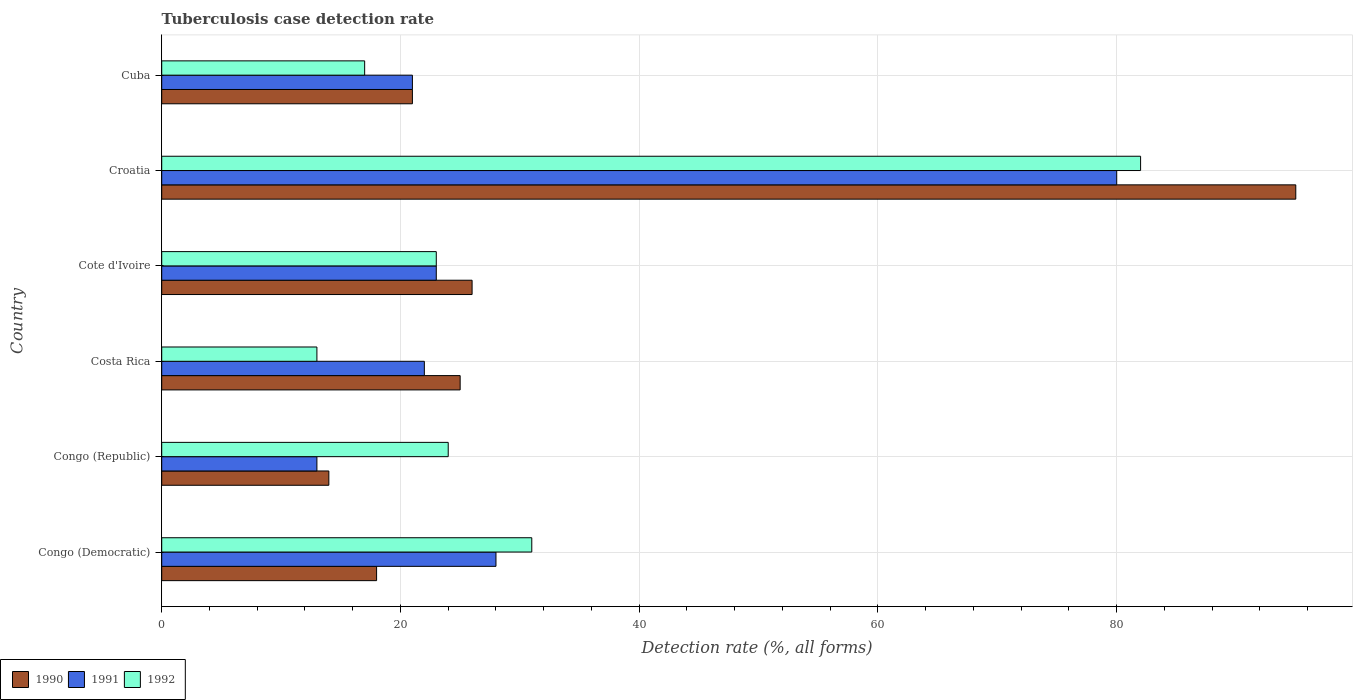How many groups of bars are there?
Make the answer very short. 6. Are the number of bars per tick equal to the number of legend labels?
Give a very brief answer. Yes. How many bars are there on the 4th tick from the bottom?
Keep it short and to the point. 3. What is the label of the 1st group of bars from the top?
Give a very brief answer. Cuba. In how many cases, is the number of bars for a given country not equal to the number of legend labels?
Provide a short and direct response. 0. What is the tuberculosis case detection rate in in 1992 in Croatia?
Your answer should be compact. 82. Across all countries, what is the maximum tuberculosis case detection rate in in 1992?
Give a very brief answer. 82. In which country was the tuberculosis case detection rate in in 1992 maximum?
Keep it short and to the point. Croatia. What is the total tuberculosis case detection rate in in 1991 in the graph?
Provide a succinct answer. 187. What is the difference between the tuberculosis case detection rate in in 1992 in Croatia and that in Cuba?
Your response must be concise. 65. What is the difference between the tuberculosis case detection rate in in 1990 in Costa Rica and the tuberculosis case detection rate in in 1991 in Congo (Democratic)?
Offer a very short reply. -3. What is the average tuberculosis case detection rate in in 1990 per country?
Your answer should be very brief. 33.17. What is the difference between the tuberculosis case detection rate in in 1990 and tuberculosis case detection rate in in 1991 in Cuba?
Your response must be concise. 0. In how many countries, is the tuberculosis case detection rate in in 1991 greater than 76 %?
Provide a short and direct response. 1. What is the ratio of the tuberculosis case detection rate in in 1990 in Costa Rica to that in Croatia?
Offer a terse response. 0.26. What is the difference between the highest and the lowest tuberculosis case detection rate in in 1990?
Your answer should be compact. 81. In how many countries, is the tuberculosis case detection rate in in 1990 greater than the average tuberculosis case detection rate in in 1990 taken over all countries?
Keep it short and to the point. 1. Is it the case that in every country, the sum of the tuberculosis case detection rate in in 1992 and tuberculosis case detection rate in in 1991 is greater than the tuberculosis case detection rate in in 1990?
Provide a short and direct response. Yes. What is the difference between two consecutive major ticks on the X-axis?
Provide a succinct answer. 20. Does the graph contain any zero values?
Provide a succinct answer. No. Does the graph contain grids?
Provide a succinct answer. Yes. How many legend labels are there?
Provide a succinct answer. 3. What is the title of the graph?
Offer a terse response. Tuberculosis case detection rate. What is the label or title of the X-axis?
Make the answer very short. Detection rate (%, all forms). What is the Detection rate (%, all forms) in 1990 in Congo (Democratic)?
Your answer should be compact. 18. What is the Detection rate (%, all forms) of 1991 in Congo (Democratic)?
Your answer should be very brief. 28. What is the Detection rate (%, all forms) in 1990 in Congo (Republic)?
Provide a succinct answer. 14. What is the Detection rate (%, all forms) of 1991 in Congo (Republic)?
Give a very brief answer. 13. What is the Detection rate (%, all forms) in 1992 in Costa Rica?
Provide a succinct answer. 13. What is the Detection rate (%, all forms) of 1990 in Cote d'Ivoire?
Your answer should be very brief. 26. What is the Detection rate (%, all forms) in 1991 in Cote d'Ivoire?
Offer a terse response. 23. What is the Detection rate (%, all forms) in 1992 in Croatia?
Provide a succinct answer. 82. What is the Detection rate (%, all forms) in 1990 in Cuba?
Offer a terse response. 21. What is the Detection rate (%, all forms) of 1991 in Cuba?
Offer a terse response. 21. Across all countries, what is the maximum Detection rate (%, all forms) in 1990?
Offer a terse response. 95. Across all countries, what is the maximum Detection rate (%, all forms) in 1991?
Ensure brevity in your answer.  80. Across all countries, what is the minimum Detection rate (%, all forms) of 1990?
Your answer should be very brief. 14. Across all countries, what is the minimum Detection rate (%, all forms) of 1991?
Provide a succinct answer. 13. What is the total Detection rate (%, all forms) of 1990 in the graph?
Keep it short and to the point. 199. What is the total Detection rate (%, all forms) of 1991 in the graph?
Your response must be concise. 187. What is the total Detection rate (%, all forms) of 1992 in the graph?
Give a very brief answer. 190. What is the difference between the Detection rate (%, all forms) in 1992 in Congo (Democratic) and that in Congo (Republic)?
Keep it short and to the point. 7. What is the difference between the Detection rate (%, all forms) of 1992 in Congo (Democratic) and that in Costa Rica?
Provide a short and direct response. 18. What is the difference between the Detection rate (%, all forms) in 1990 in Congo (Democratic) and that in Cote d'Ivoire?
Keep it short and to the point. -8. What is the difference between the Detection rate (%, all forms) in 1991 in Congo (Democratic) and that in Cote d'Ivoire?
Your answer should be very brief. 5. What is the difference between the Detection rate (%, all forms) in 1992 in Congo (Democratic) and that in Cote d'Ivoire?
Your response must be concise. 8. What is the difference between the Detection rate (%, all forms) in 1990 in Congo (Democratic) and that in Croatia?
Offer a very short reply. -77. What is the difference between the Detection rate (%, all forms) in 1991 in Congo (Democratic) and that in Croatia?
Make the answer very short. -52. What is the difference between the Detection rate (%, all forms) of 1992 in Congo (Democratic) and that in Croatia?
Your answer should be compact. -51. What is the difference between the Detection rate (%, all forms) in 1990 in Congo (Democratic) and that in Cuba?
Provide a short and direct response. -3. What is the difference between the Detection rate (%, all forms) in 1991 in Congo (Democratic) and that in Cuba?
Your answer should be very brief. 7. What is the difference between the Detection rate (%, all forms) of 1992 in Congo (Democratic) and that in Cuba?
Provide a short and direct response. 14. What is the difference between the Detection rate (%, all forms) in 1991 in Congo (Republic) and that in Costa Rica?
Offer a terse response. -9. What is the difference between the Detection rate (%, all forms) of 1991 in Congo (Republic) and that in Cote d'Ivoire?
Your answer should be compact. -10. What is the difference between the Detection rate (%, all forms) of 1992 in Congo (Republic) and that in Cote d'Ivoire?
Ensure brevity in your answer.  1. What is the difference between the Detection rate (%, all forms) of 1990 in Congo (Republic) and that in Croatia?
Ensure brevity in your answer.  -81. What is the difference between the Detection rate (%, all forms) in 1991 in Congo (Republic) and that in Croatia?
Your answer should be compact. -67. What is the difference between the Detection rate (%, all forms) in 1992 in Congo (Republic) and that in Croatia?
Your answer should be compact. -58. What is the difference between the Detection rate (%, all forms) of 1990 in Congo (Republic) and that in Cuba?
Provide a succinct answer. -7. What is the difference between the Detection rate (%, all forms) of 1991 in Congo (Republic) and that in Cuba?
Keep it short and to the point. -8. What is the difference between the Detection rate (%, all forms) in 1992 in Congo (Republic) and that in Cuba?
Keep it short and to the point. 7. What is the difference between the Detection rate (%, all forms) of 1991 in Costa Rica and that in Cote d'Ivoire?
Make the answer very short. -1. What is the difference between the Detection rate (%, all forms) of 1992 in Costa Rica and that in Cote d'Ivoire?
Provide a succinct answer. -10. What is the difference between the Detection rate (%, all forms) in 1990 in Costa Rica and that in Croatia?
Provide a succinct answer. -70. What is the difference between the Detection rate (%, all forms) of 1991 in Costa Rica and that in Croatia?
Ensure brevity in your answer.  -58. What is the difference between the Detection rate (%, all forms) in 1992 in Costa Rica and that in Croatia?
Provide a succinct answer. -69. What is the difference between the Detection rate (%, all forms) in 1990 in Costa Rica and that in Cuba?
Provide a short and direct response. 4. What is the difference between the Detection rate (%, all forms) of 1991 in Costa Rica and that in Cuba?
Your answer should be compact. 1. What is the difference between the Detection rate (%, all forms) in 1992 in Costa Rica and that in Cuba?
Ensure brevity in your answer.  -4. What is the difference between the Detection rate (%, all forms) of 1990 in Cote d'Ivoire and that in Croatia?
Make the answer very short. -69. What is the difference between the Detection rate (%, all forms) of 1991 in Cote d'Ivoire and that in Croatia?
Offer a very short reply. -57. What is the difference between the Detection rate (%, all forms) of 1992 in Cote d'Ivoire and that in Croatia?
Your answer should be very brief. -59. What is the difference between the Detection rate (%, all forms) in 1991 in Croatia and that in Cuba?
Make the answer very short. 59. What is the difference between the Detection rate (%, all forms) of 1990 in Congo (Democratic) and the Detection rate (%, all forms) of 1992 in Costa Rica?
Offer a very short reply. 5. What is the difference between the Detection rate (%, all forms) in 1991 in Congo (Democratic) and the Detection rate (%, all forms) in 1992 in Cote d'Ivoire?
Your answer should be compact. 5. What is the difference between the Detection rate (%, all forms) of 1990 in Congo (Democratic) and the Detection rate (%, all forms) of 1991 in Croatia?
Give a very brief answer. -62. What is the difference between the Detection rate (%, all forms) of 1990 in Congo (Democratic) and the Detection rate (%, all forms) of 1992 in Croatia?
Ensure brevity in your answer.  -64. What is the difference between the Detection rate (%, all forms) of 1991 in Congo (Democratic) and the Detection rate (%, all forms) of 1992 in Croatia?
Provide a succinct answer. -54. What is the difference between the Detection rate (%, all forms) of 1990 in Congo (Democratic) and the Detection rate (%, all forms) of 1991 in Cuba?
Keep it short and to the point. -3. What is the difference between the Detection rate (%, all forms) of 1990 in Congo (Democratic) and the Detection rate (%, all forms) of 1992 in Cuba?
Keep it short and to the point. 1. What is the difference between the Detection rate (%, all forms) of 1990 in Congo (Republic) and the Detection rate (%, all forms) of 1991 in Costa Rica?
Offer a terse response. -8. What is the difference between the Detection rate (%, all forms) in 1990 in Congo (Republic) and the Detection rate (%, all forms) in 1992 in Costa Rica?
Your response must be concise. 1. What is the difference between the Detection rate (%, all forms) in 1991 in Congo (Republic) and the Detection rate (%, all forms) in 1992 in Costa Rica?
Your response must be concise. 0. What is the difference between the Detection rate (%, all forms) of 1991 in Congo (Republic) and the Detection rate (%, all forms) of 1992 in Cote d'Ivoire?
Your answer should be very brief. -10. What is the difference between the Detection rate (%, all forms) in 1990 in Congo (Republic) and the Detection rate (%, all forms) in 1991 in Croatia?
Make the answer very short. -66. What is the difference between the Detection rate (%, all forms) of 1990 in Congo (Republic) and the Detection rate (%, all forms) of 1992 in Croatia?
Your response must be concise. -68. What is the difference between the Detection rate (%, all forms) of 1991 in Congo (Republic) and the Detection rate (%, all forms) of 1992 in Croatia?
Offer a terse response. -69. What is the difference between the Detection rate (%, all forms) of 1991 in Congo (Republic) and the Detection rate (%, all forms) of 1992 in Cuba?
Provide a succinct answer. -4. What is the difference between the Detection rate (%, all forms) of 1990 in Costa Rica and the Detection rate (%, all forms) of 1991 in Croatia?
Offer a terse response. -55. What is the difference between the Detection rate (%, all forms) of 1990 in Costa Rica and the Detection rate (%, all forms) of 1992 in Croatia?
Your response must be concise. -57. What is the difference between the Detection rate (%, all forms) of 1991 in Costa Rica and the Detection rate (%, all forms) of 1992 in Croatia?
Offer a very short reply. -60. What is the difference between the Detection rate (%, all forms) of 1990 in Costa Rica and the Detection rate (%, all forms) of 1992 in Cuba?
Keep it short and to the point. 8. What is the difference between the Detection rate (%, all forms) in 1991 in Costa Rica and the Detection rate (%, all forms) in 1992 in Cuba?
Provide a short and direct response. 5. What is the difference between the Detection rate (%, all forms) of 1990 in Cote d'Ivoire and the Detection rate (%, all forms) of 1991 in Croatia?
Make the answer very short. -54. What is the difference between the Detection rate (%, all forms) in 1990 in Cote d'Ivoire and the Detection rate (%, all forms) in 1992 in Croatia?
Keep it short and to the point. -56. What is the difference between the Detection rate (%, all forms) in 1991 in Cote d'Ivoire and the Detection rate (%, all forms) in 1992 in Croatia?
Give a very brief answer. -59. What is the difference between the Detection rate (%, all forms) in 1990 in Cote d'Ivoire and the Detection rate (%, all forms) in 1991 in Cuba?
Give a very brief answer. 5. What is the difference between the Detection rate (%, all forms) of 1990 in Cote d'Ivoire and the Detection rate (%, all forms) of 1992 in Cuba?
Make the answer very short. 9. What is the difference between the Detection rate (%, all forms) of 1991 in Cote d'Ivoire and the Detection rate (%, all forms) of 1992 in Cuba?
Ensure brevity in your answer.  6. What is the difference between the Detection rate (%, all forms) of 1990 in Croatia and the Detection rate (%, all forms) of 1991 in Cuba?
Offer a terse response. 74. What is the difference between the Detection rate (%, all forms) in 1990 in Croatia and the Detection rate (%, all forms) in 1992 in Cuba?
Provide a succinct answer. 78. What is the difference between the Detection rate (%, all forms) of 1991 in Croatia and the Detection rate (%, all forms) of 1992 in Cuba?
Offer a terse response. 63. What is the average Detection rate (%, all forms) in 1990 per country?
Provide a succinct answer. 33.17. What is the average Detection rate (%, all forms) in 1991 per country?
Offer a very short reply. 31.17. What is the average Detection rate (%, all forms) in 1992 per country?
Provide a succinct answer. 31.67. What is the difference between the Detection rate (%, all forms) of 1990 and Detection rate (%, all forms) of 1992 in Congo (Democratic)?
Give a very brief answer. -13. What is the difference between the Detection rate (%, all forms) in 1991 and Detection rate (%, all forms) in 1992 in Congo (Democratic)?
Your answer should be very brief. -3. What is the difference between the Detection rate (%, all forms) of 1990 and Detection rate (%, all forms) of 1992 in Congo (Republic)?
Provide a short and direct response. -10. What is the difference between the Detection rate (%, all forms) of 1990 and Detection rate (%, all forms) of 1991 in Costa Rica?
Your answer should be very brief. 3. What is the difference between the Detection rate (%, all forms) of 1991 and Detection rate (%, all forms) of 1992 in Costa Rica?
Make the answer very short. 9. What is the difference between the Detection rate (%, all forms) of 1990 and Detection rate (%, all forms) of 1991 in Cote d'Ivoire?
Keep it short and to the point. 3. What is the difference between the Detection rate (%, all forms) in 1991 and Detection rate (%, all forms) in 1992 in Cote d'Ivoire?
Your answer should be compact. 0. What is the difference between the Detection rate (%, all forms) of 1990 and Detection rate (%, all forms) of 1992 in Croatia?
Offer a very short reply. 13. What is the difference between the Detection rate (%, all forms) in 1990 and Detection rate (%, all forms) in 1991 in Cuba?
Ensure brevity in your answer.  0. What is the ratio of the Detection rate (%, all forms) of 1991 in Congo (Democratic) to that in Congo (Republic)?
Ensure brevity in your answer.  2.15. What is the ratio of the Detection rate (%, all forms) of 1992 in Congo (Democratic) to that in Congo (Republic)?
Your response must be concise. 1.29. What is the ratio of the Detection rate (%, all forms) of 1990 in Congo (Democratic) to that in Costa Rica?
Make the answer very short. 0.72. What is the ratio of the Detection rate (%, all forms) in 1991 in Congo (Democratic) to that in Costa Rica?
Your response must be concise. 1.27. What is the ratio of the Detection rate (%, all forms) in 1992 in Congo (Democratic) to that in Costa Rica?
Offer a very short reply. 2.38. What is the ratio of the Detection rate (%, all forms) in 1990 in Congo (Democratic) to that in Cote d'Ivoire?
Provide a short and direct response. 0.69. What is the ratio of the Detection rate (%, all forms) in 1991 in Congo (Democratic) to that in Cote d'Ivoire?
Make the answer very short. 1.22. What is the ratio of the Detection rate (%, all forms) in 1992 in Congo (Democratic) to that in Cote d'Ivoire?
Offer a terse response. 1.35. What is the ratio of the Detection rate (%, all forms) of 1990 in Congo (Democratic) to that in Croatia?
Make the answer very short. 0.19. What is the ratio of the Detection rate (%, all forms) of 1992 in Congo (Democratic) to that in Croatia?
Your answer should be very brief. 0.38. What is the ratio of the Detection rate (%, all forms) in 1991 in Congo (Democratic) to that in Cuba?
Keep it short and to the point. 1.33. What is the ratio of the Detection rate (%, all forms) in 1992 in Congo (Democratic) to that in Cuba?
Your response must be concise. 1.82. What is the ratio of the Detection rate (%, all forms) of 1990 in Congo (Republic) to that in Costa Rica?
Your answer should be very brief. 0.56. What is the ratio of the Detection rate (%, all forms) in 1991 in Congo (Republic) to that in Costa Rica?
Offer a very short reply. 0.59. What is the ratio of the Detection rate (%, all forms) in 1992 in Congo (Republic) to that in Costa Rica?
Your answer should be very brief. 1.85. What is the ratio of the Detection rate (%, all forms) in 1990 in Congo (Republic) to that in Cote d'Ivoire?
Offer a very short reply. 0.54. What is the ratio of the Detection rate (%, all forms) of 1991 in Congo (Republic) to that in Cote d'Ivoire?
Your answer should be compact. 0.57. What is the ratio of the Detection rate (%, all forms) of 1992 in Congo (Republic) to that in Cote d'Ivoire?
Provide a succinct answer. 1.04. What is the ratio of the Detection rate (%, all forms) in 1990 in Congo (Republic) to that in Croatia?
Ensure brevity in your answer.  0.15. What is the ratio of the Detection rate (%, all forms) of 1991 in Congo (Republic) to that in Croatia?
Give a very brief answer. 0.16. What is the ratio of the Detection rate (%, all forms) in 1992 in Congo (Republic) to that in Croatia?
Offer a very short reply. 0.29. What is the ratio of the Detection rate (%, all forms) of 1990 in Congo (Republic) to that in Cuba?
Your response must be concise. 0.67. What is the ratio of the Detection rate (%, all forms) in 1991 in Congo (Republic) to that in Cuba?
Your answer should be very brief. 0.62. What is the ratio of the Detection rate (%, all forms) in 1992 in Congo (Republic) to that in Cuba?
Your answer should be very brief. 1.41. What is the ratio of the Detection rate (%, all forms) in 1990 in Costa Rica to that in Cote d'Ivoire?
Keep it short and to the point. 0.96. What is the ratio of the Detection rate (%, all forms) in 1991 in Costa Rica to that in Cote d'Ivoire?
Give a very brief answer. 0.96. What is the ratio of the Detection rate (%, all forms) of 1992 in Costa Rica to that in Cote d'Ivoire?
Your response must be concise. 0.57. What is the ratio of the Detection rate (%, all forms) in 1990 in Costa Rica to that in Croatia?
Keep it short and to the point. 0.26. What is the ratio of the Detection rate (%, all forms) of 1991 in Costa Rica to that in Croatia?
Make the answer very short. 0.28. What is the ratio of the Detection rate (%, all forms) of 1992 in Costa Rica to that in Croatia?
Give a very brief answer. 0.16. What is the ratio of the Detection rate (%, all forms) of 1990 in Costa Rica to that in Cuba?
Make the answer very short. 1.19. What is the ratio of the Detection rate (%, all forms) of 1991 in Costa Rica to that in Cuba?
Your answer should be very brief. 1.05. What is the ratio of the Detection rate (%, all forms) in 1992 in Costa Rica to that in Cuba?
Keep it short and to the point. 0.76. What is the ratio of the Detection rate (%, all forms) of 1990 in Cote d'Ivoire to that in Croatia?
Your answer should be compact. 0.27. What is the ratio of the Detection rate (%, all forms) of 1991 in Cote d'Ivoire to that in Croatia?
Offer a terse response. 0.29. What is the ratio of the Detection rate (%, all forms) of 1992 in Cote d'Ivoire to that in Croatia?
Your answer should be compact. 0.28. What is the ratio of the Detection rate (%, all forms) of 1990 in Cote d'Ivoire to that in Cuba?
Your response must be concise. 1.24. What is the ratio of the Detection rate (%, all forms) in 1991 in Cote d'Ivoire to that in Cuba?
Offer a very short reply. 1.1. What is the ratio of the Detection rate (%, all forms) of 1992 in Cote d'Ivoire to that in Cuba?
Offer a terse response. 1.35. What is the ratio of the Detection rate (%, all forms) of 1990 in Croatia to that in Cuba?
Your response must be concise. 4.52. What is the ratio of the Detection rate (%, all forms) of 1991 in Croatia to that in Cuba?
Offer a very short reply. 3.81. What is the ratio of the Detection rate (%, all forms) of 1992 in Croatia to that in Cuba?
Provide a succinct answer. 4.82. What is the difference between the highest and the second highest Detection rate (%, all forms) in 1991?
Provide a short and direct response. 52. What is the difference between the highest and the lowest Detection rate (%, all forms) in 1991?
Offer a terse response. 67. 